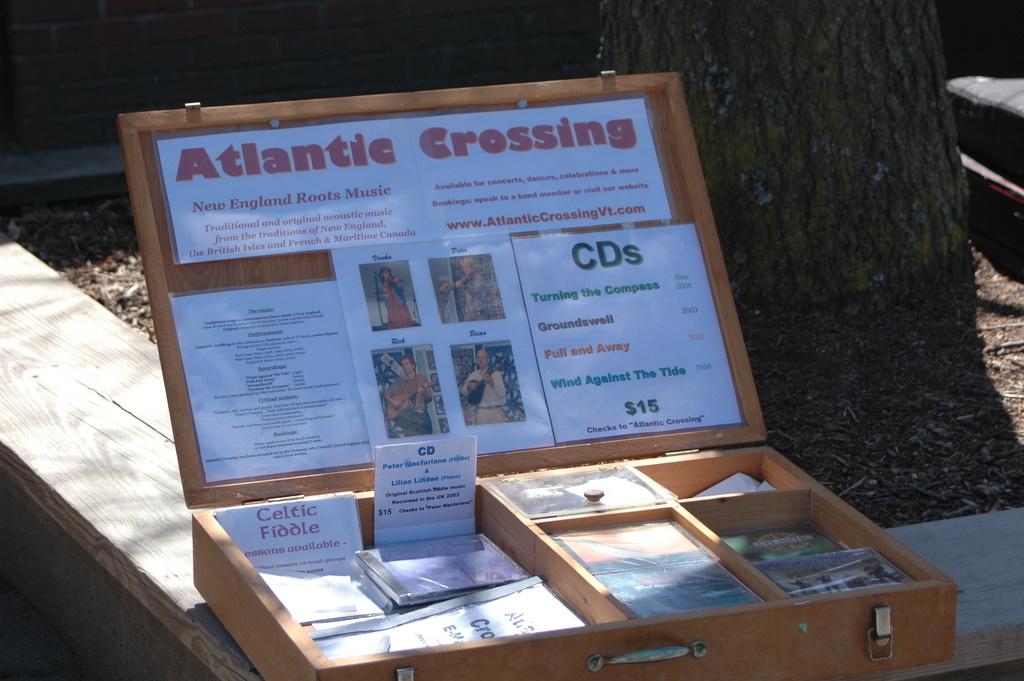How much do those cd's cost?
Provide a short and direct response. $15. What is he selling?
Provide a short and direct response. Cds. 